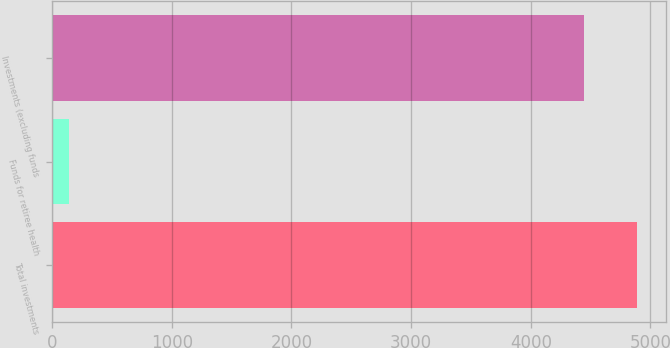Convert chart. <chart><loc_0><loc_0><loc_500><loc_500><bar_chart><fcel>Total investments<fcel>Funds for retiree health<fcel>Investments (excluding funds<nl><fcel>4888.4<fcel>145<fcel>4444<nl></chart> 